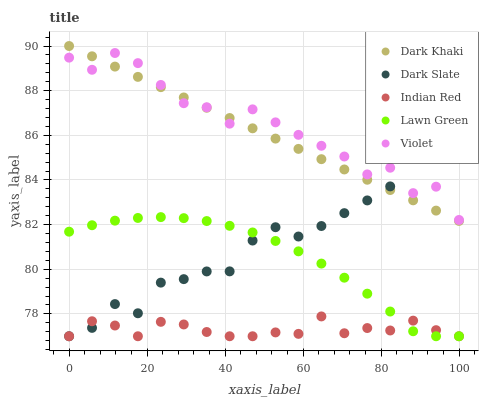Does Indian Red have the minimum area under the curve?
Answer yes or no. Yes. Does Violet have the maximum area under the curve?
Answer yes or no. Yes. Does Dark Slate have the minimum area under the curve?
Answer yes or no. No. Does Dark Slate have the maximum area under the curve?
Answer yes or no. No. Is Dark Khaki the smoothest?
Answer yes or no. Yes. Is Violet the roughest?
Answer yes or no. Yes. Is Dark Slate the smoothest?
Answer yes or no. No. Is Dark Slate the roughest?
Answer yes or no. No. Does Dark Slate have the lowest value?
Answer yes or no. Yes. Does Violet have the lowest value?
Answer yes or no. No. Does Dark Khaki have the highest value?
Answer yes or no. Yes. Does Dark Slate have the highest value?
Answer yes or no. No. Is Lawn Green less than Dark Khaki?
Answer yes or no. Yes. Is Violet greater than Lawn Green?
Answer yes or no. Yes. Does Lawn Green intersect Dark Slate?
Answer yes or no. Yes. Is Lawn Green less than Dark Slate?
Answer yes or no. No. Is Lawn Green greater than Dark Slate?
Answer yes or no. No. Does Lawn Green intersect Dark Khaki?
Answer yes or no. No. 